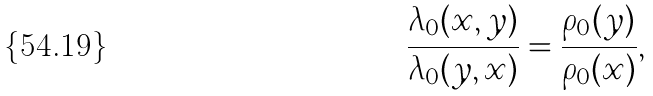<formula> <loc_0><loc_0><loc_500><loc_500>\frac { \lambda _ { 0 } ( x , y ) } { \lambda _ { 0 } ( y , x ) } = \frac { \rho _ { 0 } ( y ) } { \rho _ { 0 } ( x ) } ,</formula> 